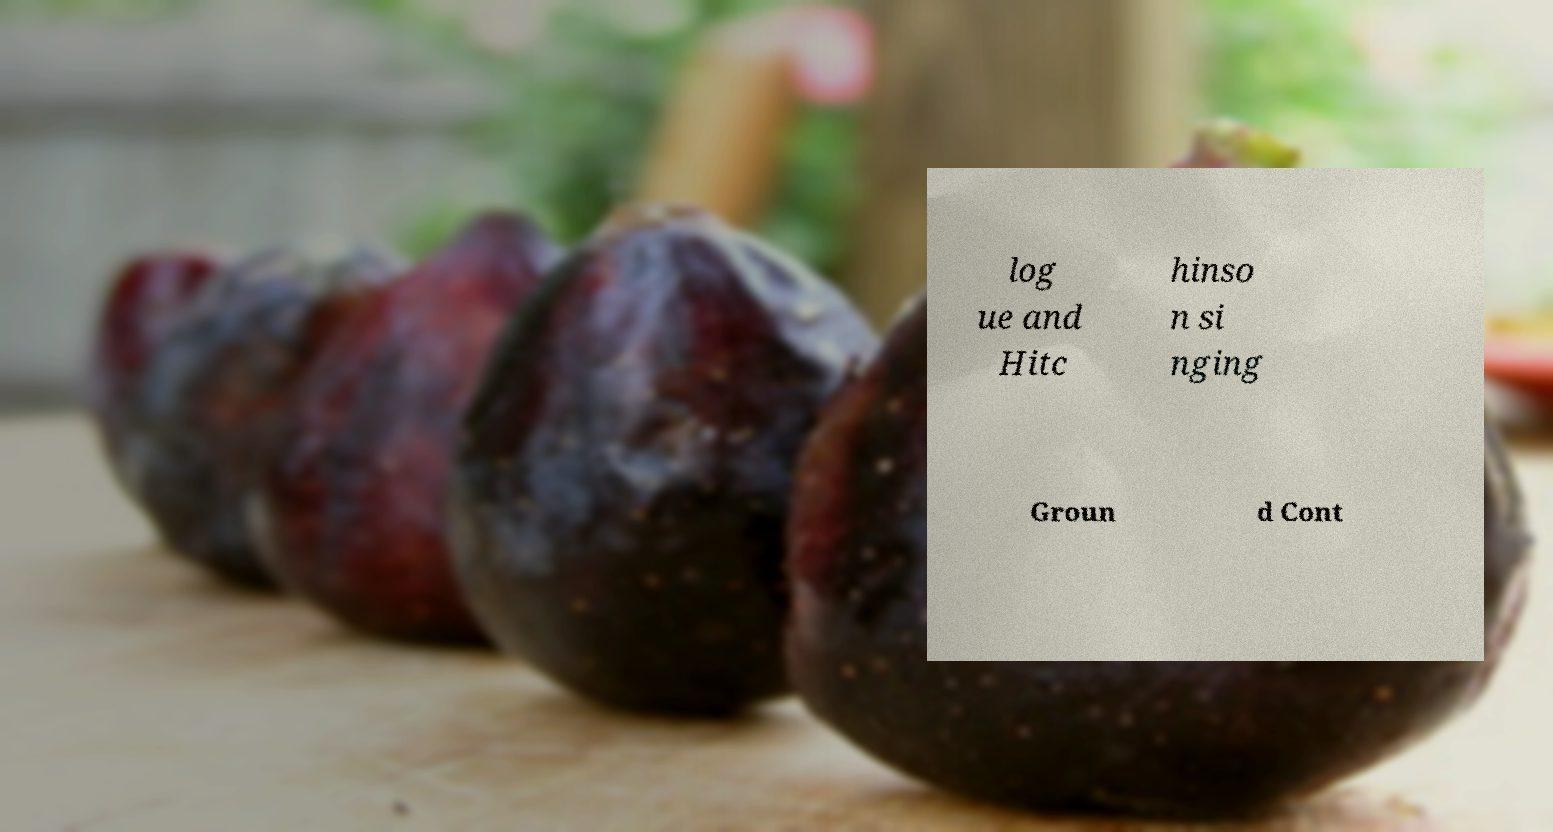Could you assist in decoding the text presented in this image and type it out clearly? log ue and Hitc hinso n si nging Groun d Cont 